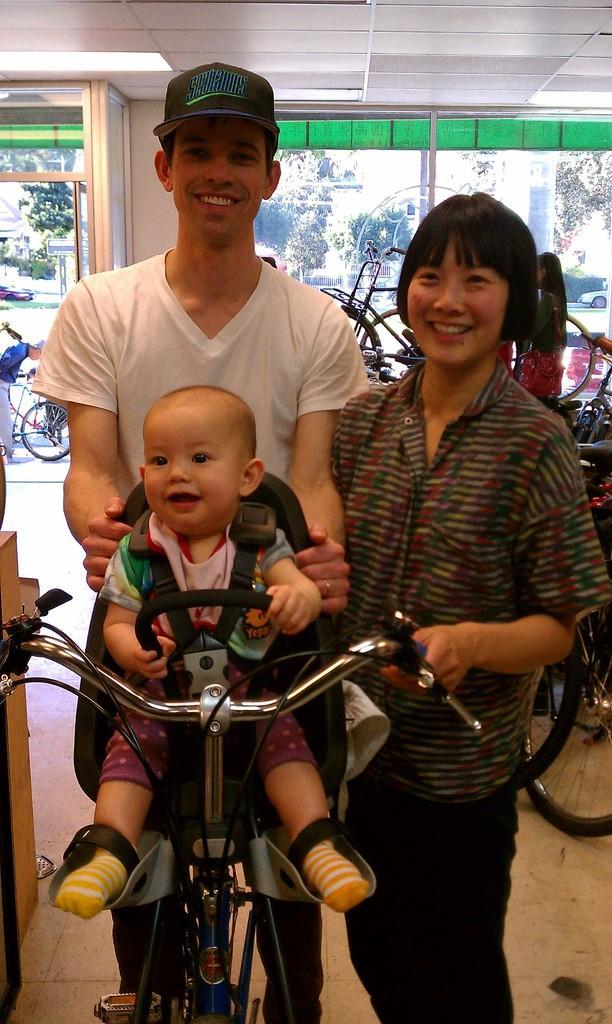Describe this image in one or two sentences. In this image, there is an inside view of a building. There are two person standing and wearing clothes. There is a kid in the bottom left of the image sitting on the cycle. There are some cycles behind these persons. 